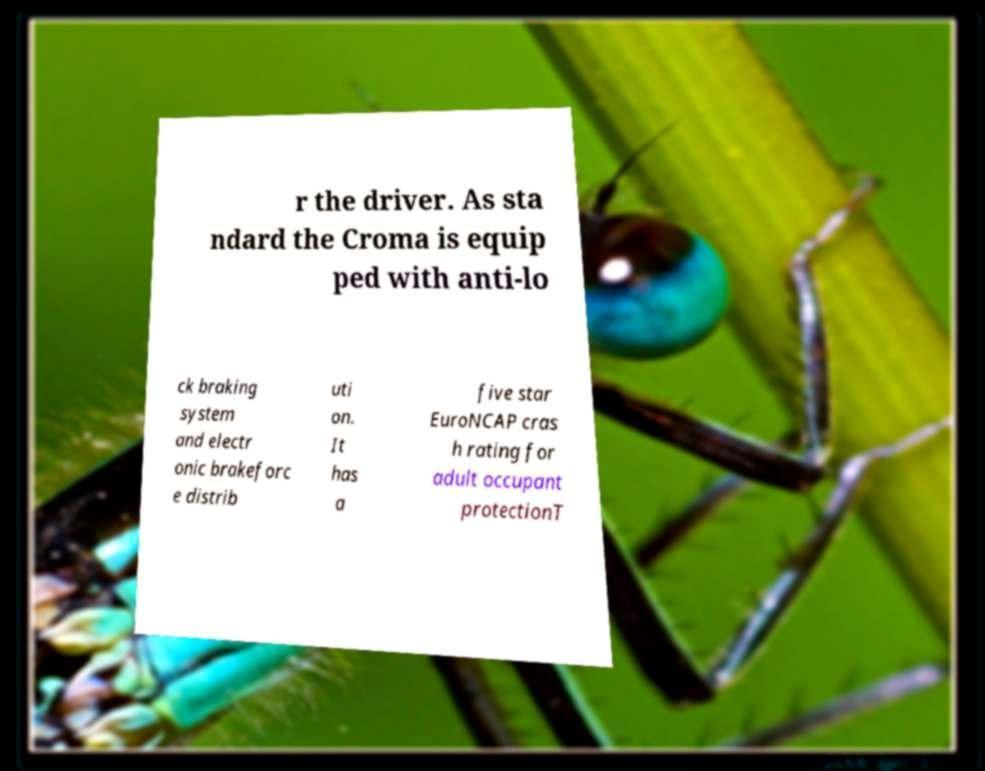There's text embedded in this image that I need extracted. Can you transcribe it verbatim? r the driver. As sta ndard the Croma is equip ped with anti-lo ck braking system and electr onic brakeforc e distrib uti on. It has a five star EuroNCAP cras h rating for adult occupant protectionT 